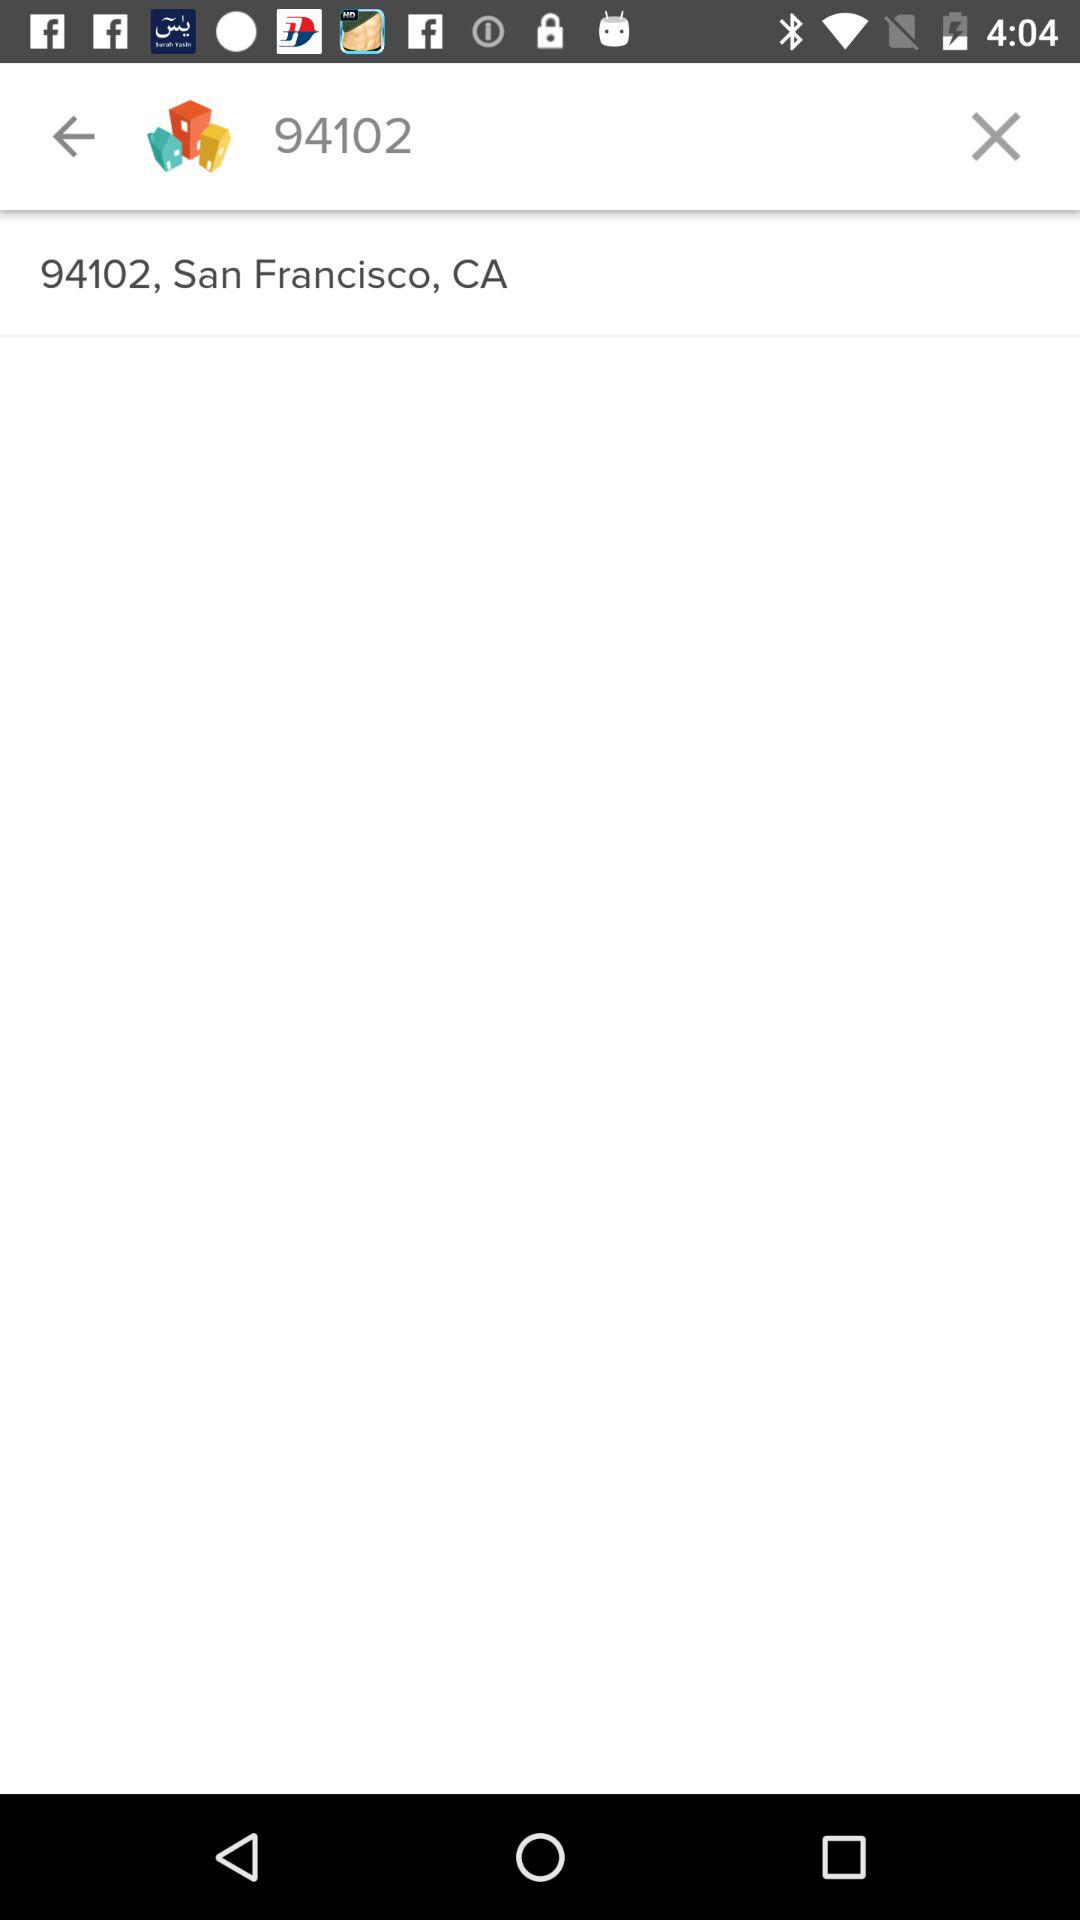What's the location? The location is 94102, San Francisco, CA. 